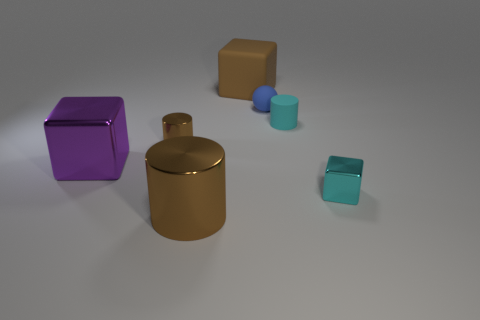Subtract all large purple blocks. How many blocks are left? 2 Add 2 tiny cylinders. How many objects exist? 9 Subtract 1 cubes. How many cubes are left? 2 Subtract all purple cubes. How many cubes are left? 2 Add 3 large metallic things. How many large metallic things are left? 5 Add 6 tiny brown things. How many tiny brown things exist? 7 Subtract 0 red cylinders. How many objects are left? 7 Subtract all spheres. How many objects are left? 6 Subtract all cyan balls. Subtract all gray blocks. How many balls are left? 1 Subtract all brown spheres. How many gray cubes are left? 0 